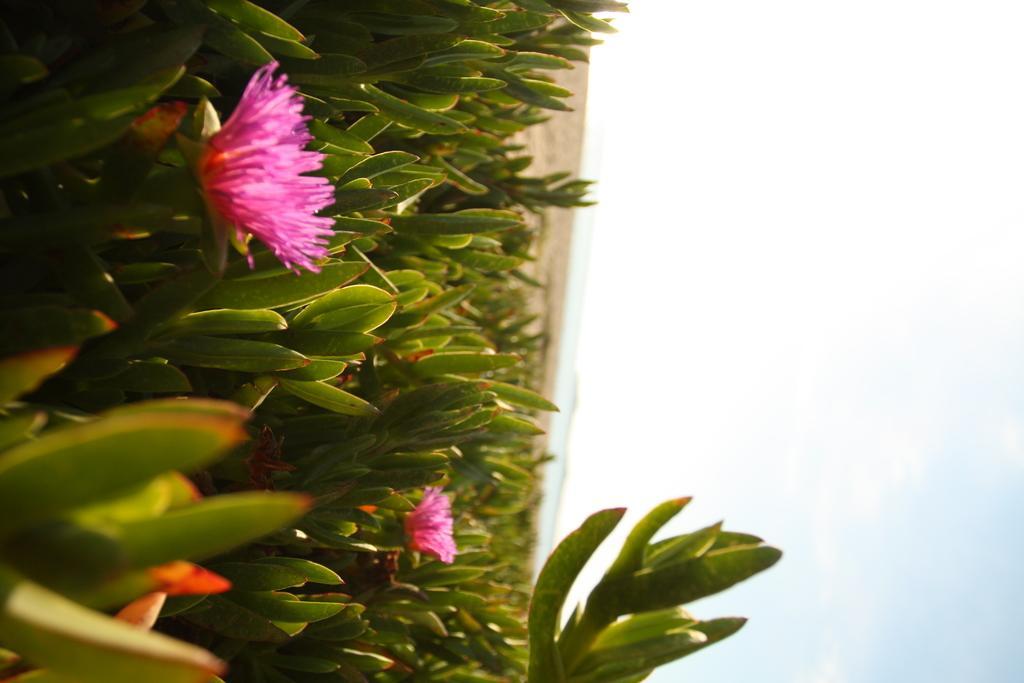Describe this image in one or two sentences. In the image there is are flowers to the plants and in the back it seems to be a sea, this is a inverted image and above its sky. 